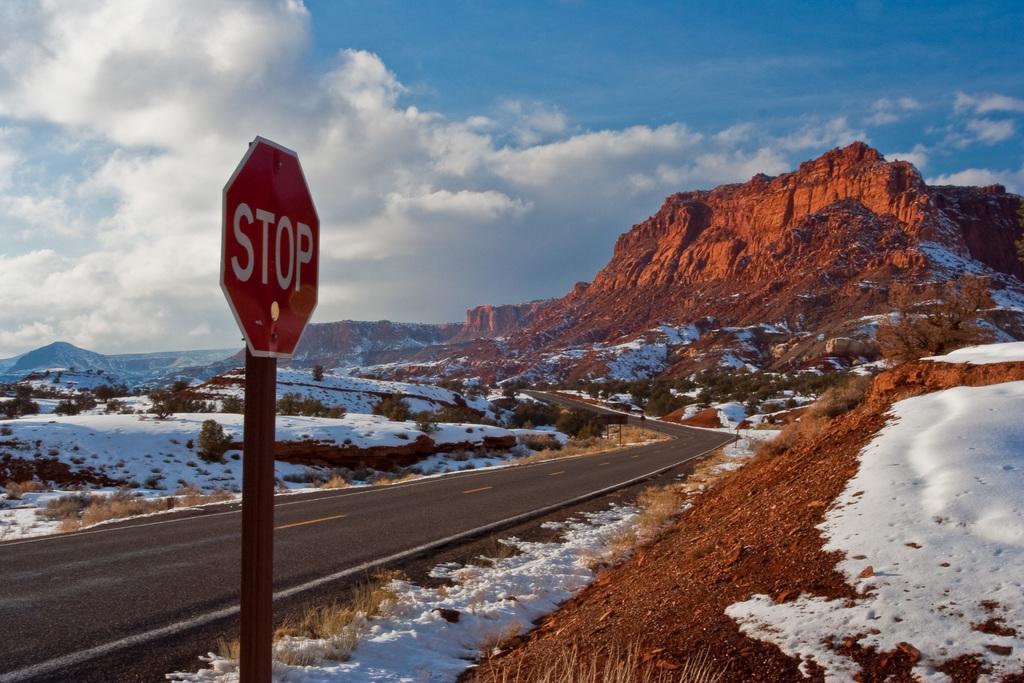What should you do at this sign?
Your answer should be compact. Stop. 